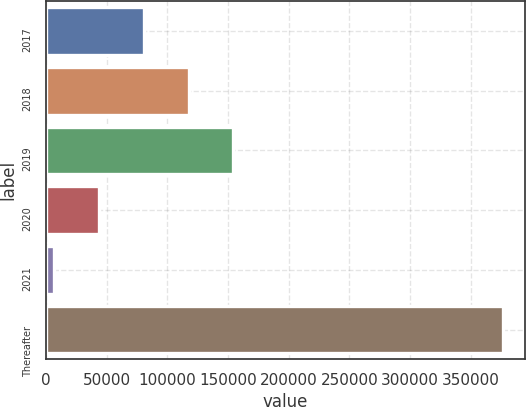<chart> <loc_0><loc_0><loc_500><loc_500><bar_chart><fcel>2017<fcel>2018<fcel>2019<fcel>2020<fcel>2021<fcel>Thereafter<nl><fcel>80611.2<fcel>117573<fcel>154534<fcel>43649.6<fcel>6688<fcel>376304<nl></chart> 